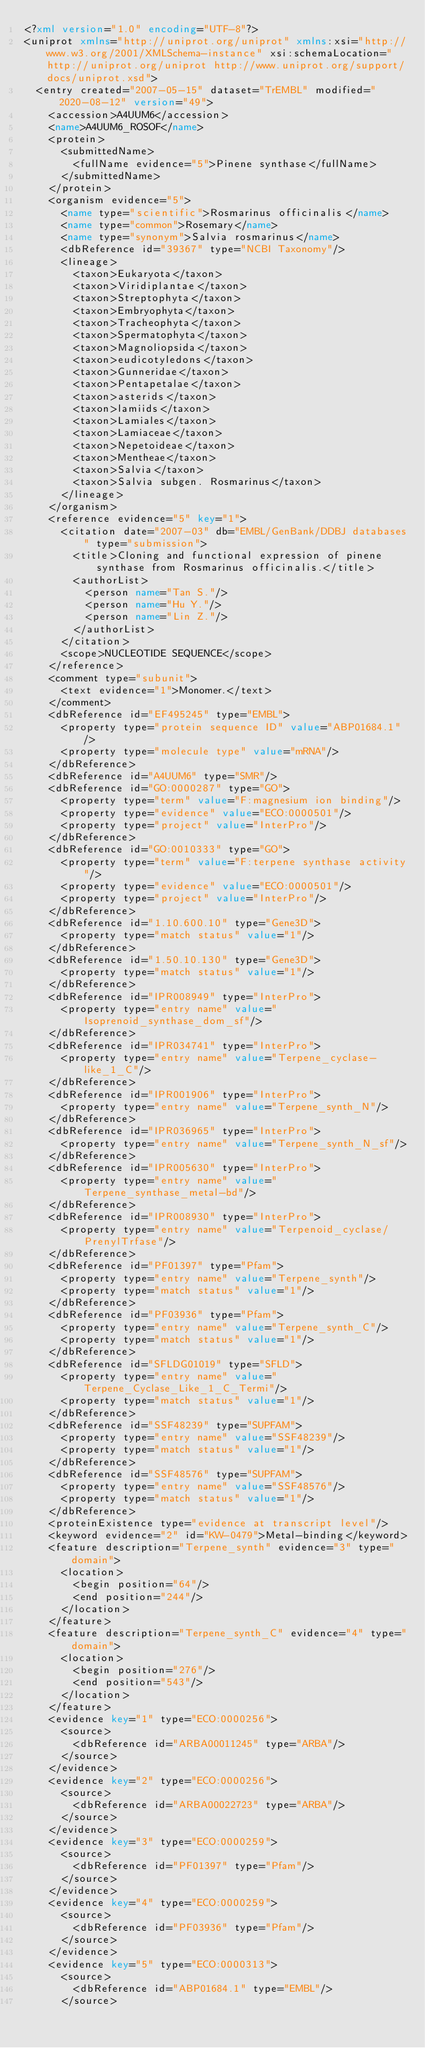Convert code to text. <code><loc_0><loc_0><loc_500><loc_500><_XML_><?xml version="1.0" encoding="UTF-8"?>
<uniprot xmlns="http://uniprot.org/uniprot" xmlns:xsi="http://www.w3.org/2001/XMLSchema-instance" xsi:schemaLocation="http://uniprot.org/uniprot http://www.uniprot.org/support/docs/uniprot.xsd">
  <entry created="2007-05-15" dataset="TrEMBL" modified="2020-08-12" version="49">
    <accession>A4UUM6</accession>
    <name>A4UUM6_ROSOF</name>
    <protein>
      <submittedName>
        <fullName evidence="5">Pinene synthase</fullName>
      </submittedName>
    </protein>
    <organism evidence="5">
      <name type="scientific">Rosmarinus officinalis</name>
      <name type="common">Rosemary</name>
      <name type="synonym">Salvia rosmarinus</name>
      <dbReference id="39367" type="NCBI Taxonomy"/>
      <lineage>
        <taxon>Eukaryota</taxon>
        <taxon>Viridiplantae</taxon>
        <taxon>Streptophyta</taxon>
        <taxon>Embryophyta</taxon>
        <taxon>Tracheophyta</taxon>
        <taxon>Spermatophyta</taxon>
        <taxon>Magnoliopsida</taxon>
        <taxon>eudicotyledons</taxon>
        <taxon>Gunneridae</taxon>
        <taxon>Pentapetalae</taxon>
        <taxon>asterids</taxon>
        <taxon>lamiids</taxon>
        <taxon>Lamiales</taxon>
        <taxon>Lamiaceae</taxon>
        <taxon>Nepetoideae</taxon>
        <taxon>Mentheae</taxon>
        <taxon>Salvia</taxon>
        <taxon>Salvia subgen. Rosmarinus</taxon>
      </lineage>
    </organism>
    <reference evidence="5" key="1">
      <citation date="2007-03" db="EMBL/GenBank/DDBJ databases" type="submission">
        <title>Cloning and functional expression of pinene synthase from Rosmarinus officinalis.</title>
        <authorList>
          <person name="Tan S."/>
          <person name="Hu Y."/>
          <person name="Lin Z."/>
        </authorList>
      </citation>
      <scope>NUCLEOTIDE SEQUENCE</scope>
    </reference>
    <comment type="subunit">
      <text evidence="1">Monomer.</text>
    </comment>
    <dbReference id="EF495245" type="EMBL">
      <property type="protein sequence ID" value="ABP01684.1"/>
      <property type="molecule type" value="mRNA"/>
    </dbReference>
    <dbReference id="A4UUM6" type="SMR"/>
    <dbReference id="GO:0000287" type="GO">
      <property type="term" value="F:magnesium ion binding"/>
      <property type="evidence" value="ECO:0000501"/>
      <property type="project" value="InterPro"/>
    </dbReference>
    <dbReference id="GO:0010333" type="GO">
      <property type="term" value="F:terpene synthase activity"/>
      <property type="evidence" value="ECO:0000501"/>
      <property type="project" value="InterPro"/>
    </dbReference>
    <dbReference id="1.10.600.10" type="Gene3D">
      <property type="match status" value="1"/>
    </dbReference>
    <dbReference id="1.50.10.130" type="Gene3D">
      <property type="match status" value="1"/>
    </dbReference>
    <dbReference id="IPR008949" type="InterPro">
      <property type="entry name" value="Isoprenoid_synthase_dom_sf"/>
    </dbReference>
    <dbReference id="IPR034741" type="InterPro">
      <property type="entry name" value="Terpene_cyclase-like_1_C"/>
    </dbReference>
    <dbReference id="IPR001906" type="InterPro">
      <property type="entry name" value="Terpene_synth_N"/>
    </dbReference>
    <dbReference id="IPR036965" type="InterPro">
      <property type="entry name" value="Terpene_synth_N_sf"/>
    </dbReference>
    <dbReference id="IPR005630" type="InterPro">
      <property type="entry name" value="Terpene_synthase_metal-bd"/>
    </dbReference>
    <dbReference id="IPR008930" type="InterPro">
      <property type="entry name" value="Terpenoid_cyclase/PrenylTrfase"/>
    </dbReference>
    <dbReference id="PF01397" type="Pfam">
      <property type="entry name" value="Terpene_synth"/>
      <property type="match status" value="1"/>
    </dbReference>
    <dbReference id="PF03936" type="Pfam">
      <property type="entry name" value="Terpene_synth_C"/>
      <property type="match status" value="1"/>
    </dbReference>
    <dbReference id="SFLDG01019" type="SFLD">
      <property type="entry name" value="Terpene_Cyclase_Like_1_C_Termi"/>
      <property type="match status" value="1"/>
    </dbReference>
    <dbReference id="SSF48239" type="SUPFAM">
      <property type="entry name" value="SSF48239"/>
      <property type="match status" value="1"/>
    </dbReference>
    <dbReference id="SSF48576" type="SUPFAM">
      <property type="entry name" value="SSF48576"/>
      <property type="match status" value="1"/>
    </dbReference>
    <proteinExistence type="evidence at transcript level"/>
    <keyword evidence="2" id="KW-0479">Metal-binding</keyword>
    <feature description="Terpene_synth" evidence="3" type="domain">
      <location>
        <begin position="64"/>
        <end position="244"/>
      </location>
    </feature>
    <feature description="Terpene_synth_C" evidence="4" type="domain">
      <location>
        <begin position="276"/>
        <end position="543"/>
      </location>
    </feature>
    <evidence key="1" type="ECO:0000256">
      <source>
        <dbReference id="ARBA00011245" type="ARBA"/>
      </source>
    </evidence>
    <evidence key="2" type="ECO:0000256">
      <source>
        <dbReference id="ARBA00022723" type="ARBA"/>
      </source>
    </evidence>
    <evidence key="3" type="ECO:0000259">
      <source>
        <dbReference id="PF01397" type="Pfam"/>
      </source>
    </evidence>
    <evidence key="4" type="ECO:0000259">
      <source>
        <dbReference id="PF03936" type="Pfam"/>
      </source>
    </evidence>
    <evidence key="5" type="ECO:0000313">
      <source>
        <dbReference id="ABP01684.1" type="EMBL"/>
      </source></code> 